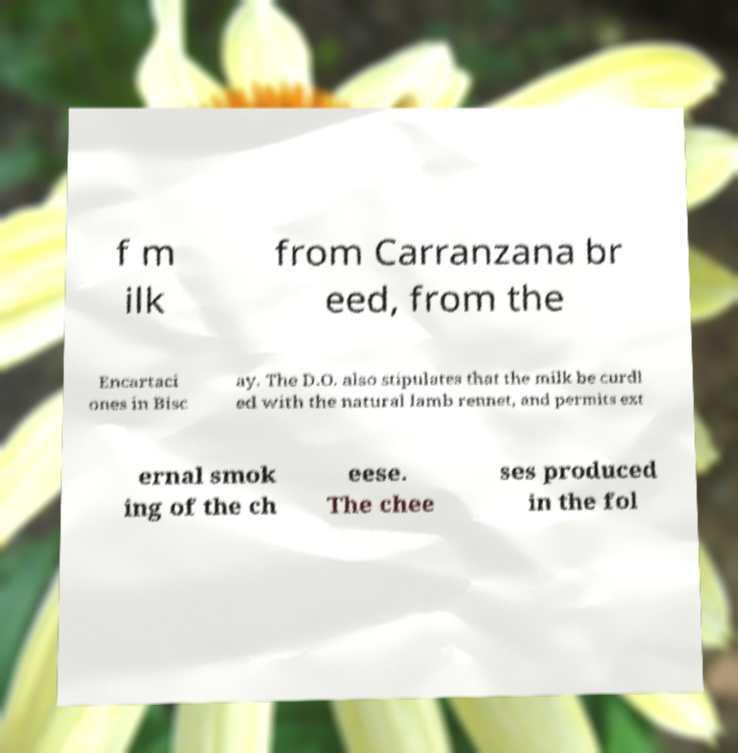I need the written content from this picture converted into text. Can you do that? f m ilk from Carranzana br eed, from the Encartaci ones in Bisc ay. The D.O. also stipulates that the milk be curdl ed with the natural lamb rennet, and permits ext ernal smok ing of the ch eese. The chee ses produced in the fol 